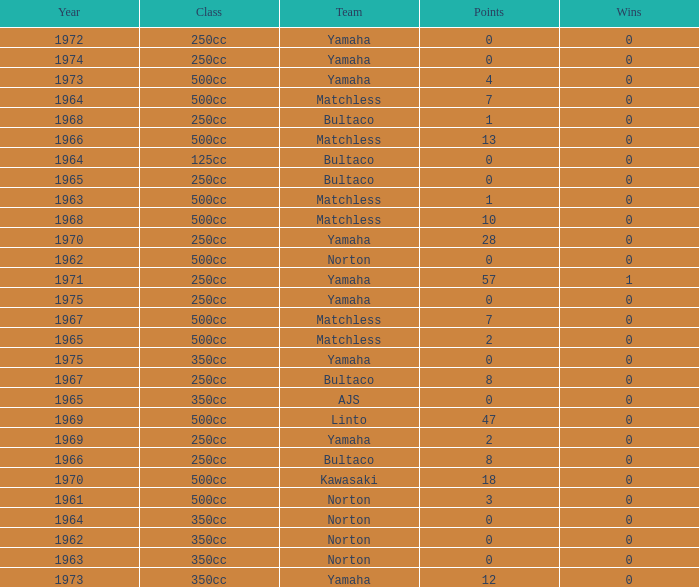What is the sum of all points in 1975 with 0 wins? None. 